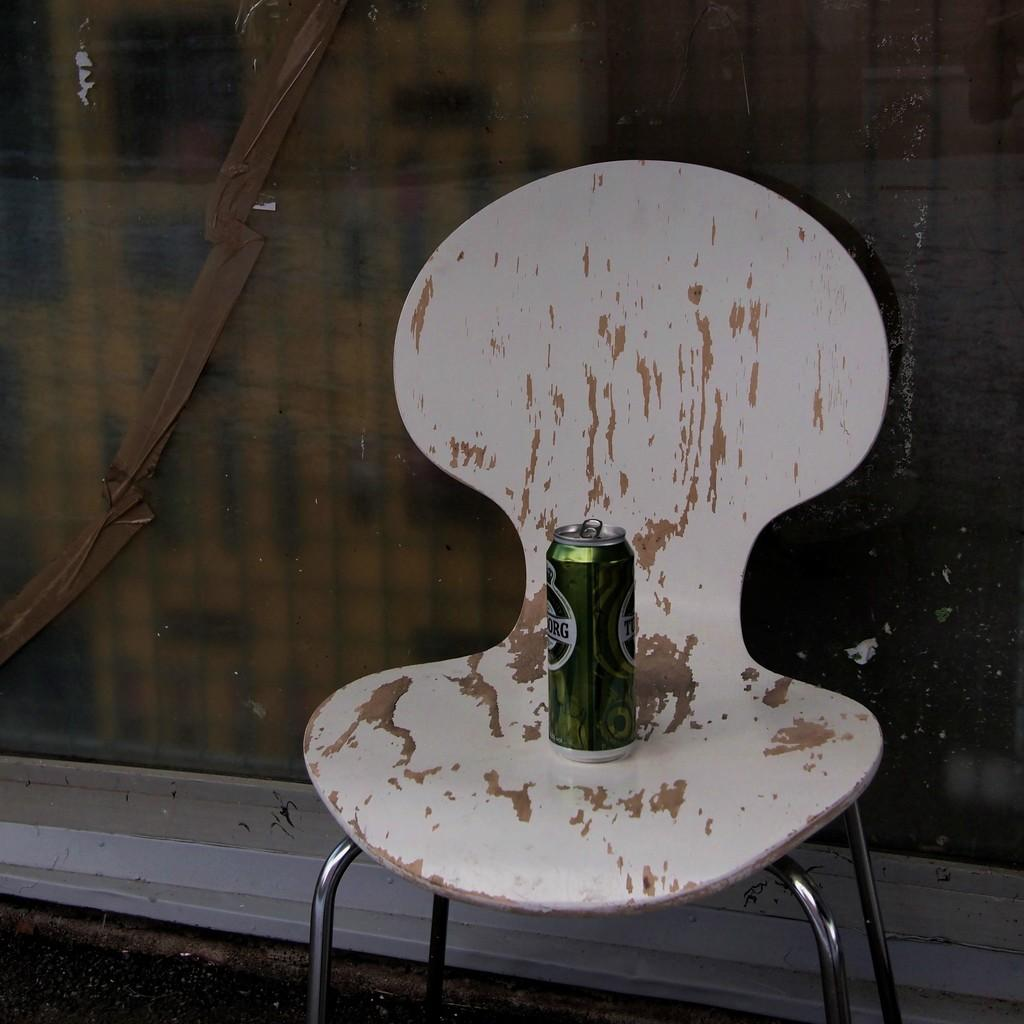What is located in the middle of the image? There is a chair in the middle of the image. What is on the chair? There is a tin on the chair. Can you describe an object in the background of the image? There is a glass in the background of the image. What is the opinion of the chair about the scene in the image? Chairs do not have opinions, as they are inanimate objects. 